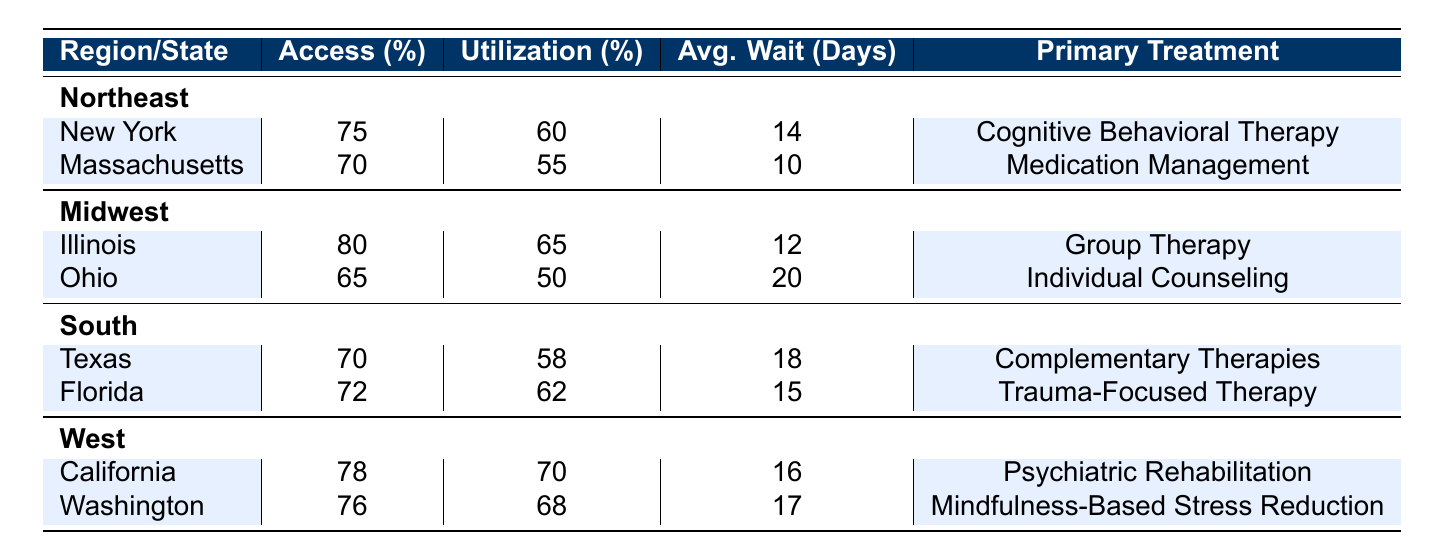What is the average access percentage for states in the South? The access percentages for Texas and Florida are 70% and 72%, respectively. To find the average, sum these values: 70 + 72 = 142. Then divide by the number of states (2): 142 / 2 = 71.
Answer: 71 Which state has the highest utilization percentage? Illinois has a utilization percentage of 65%, which is higher than any other state's percentage listed in the table.
Answer: Illinois Is the access percentage for Massachusetts higher than that for Ohio? Massachusetts has an access percentage of 70%, while Ohio has an access percentage of 65%. Since 70 is greater than 65, the statement is true.
Answer: Yes What is the primary treatment type with the longest average wait time? The treatment types are Cognitive Behavioral Therapy (14 days), Medication Management (10 days), Group Therapy (12 days), Individual Counseling (20 days), Complementary Therapies (18 days), Trauma-Focused Therapy (15 days), Psychiatric Rehabilitation (16 days), and Mindfulness-Based Stress Reduction (17 days). Individual Counseling has the longest wait time at 20 days.
Answer: Individual Counseling Which region has the highest average access percentage? The access percentages for each region are as follows: Northeast (averaging 72.5% from 75% and 70%), Midwest (72.5% from 80% and 65%), South (71% from 70% and 72%), and West (77% from 78% and 76%). Both Northeast and Midwest average the highest at 72.5%.
Answer: Northeast and Midwest If a veteran in Ohio accesses treatment, how many more days will they wait compared to a veteran in New York? Ohio's average wait time is 20 days, and New York's average wait time is 14 days. The difference is 20 - 14 = 6 days.
Answer: 6 days Are the average wait times in the West region generally lower than those in the South region? The average wait times for California and Washington in the West region are 16 and 17 days, respectively, averaging to 16.5 days. For Texas and Florida in the South, the average wait times are 18 and 15 days, respectively, averaging to 16.5 days. Therefore, the average wait times are equal.
Answer: No What is the total average wait time for all treatments listed in the table? The average wait times are: 14 (New York) + 10 (Massachusetts) + 12 (Illinois) + 20 (Ohio) + 18 (Texas) + 15 (Florida) + 16 (California) + 17 (Washington) = 132 total days. Dividing by 8 (the number of states) gives an average of 132 / 8 = 16.5 days.
Answer: 16.5 days Which treatment type has a higher utilization rate: Trauma-Focused Therapy or Group Therapy? Trauma-Focused Therapy has a utilization percentage of 62%, while Group Therapy has a utilization percentage of 65%. Since 65% is greater than 62%, Group Therapy has a higher utilization rate.
Answer: Group Therapy 